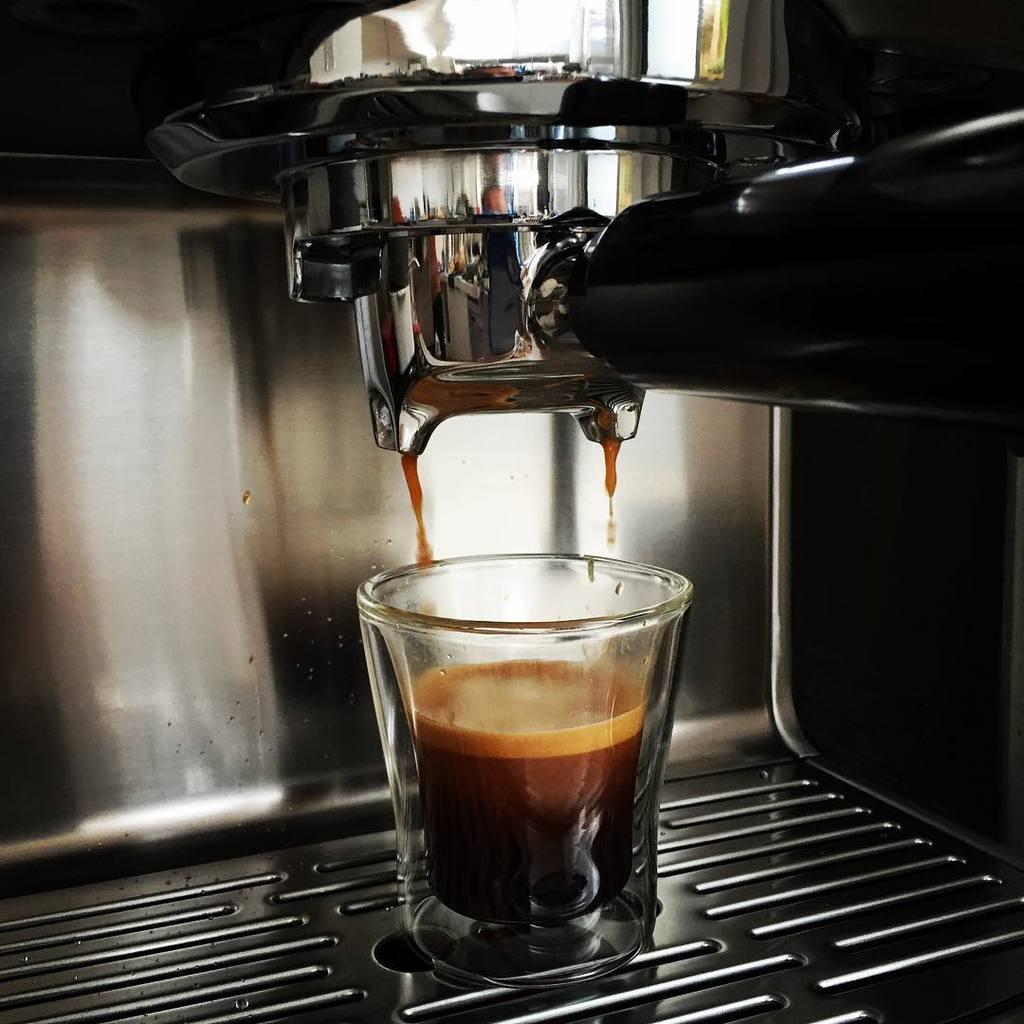Describe this image in one or two sentences. In this image there is a glass of liquid in it, and there is a kind of coffee machine. 